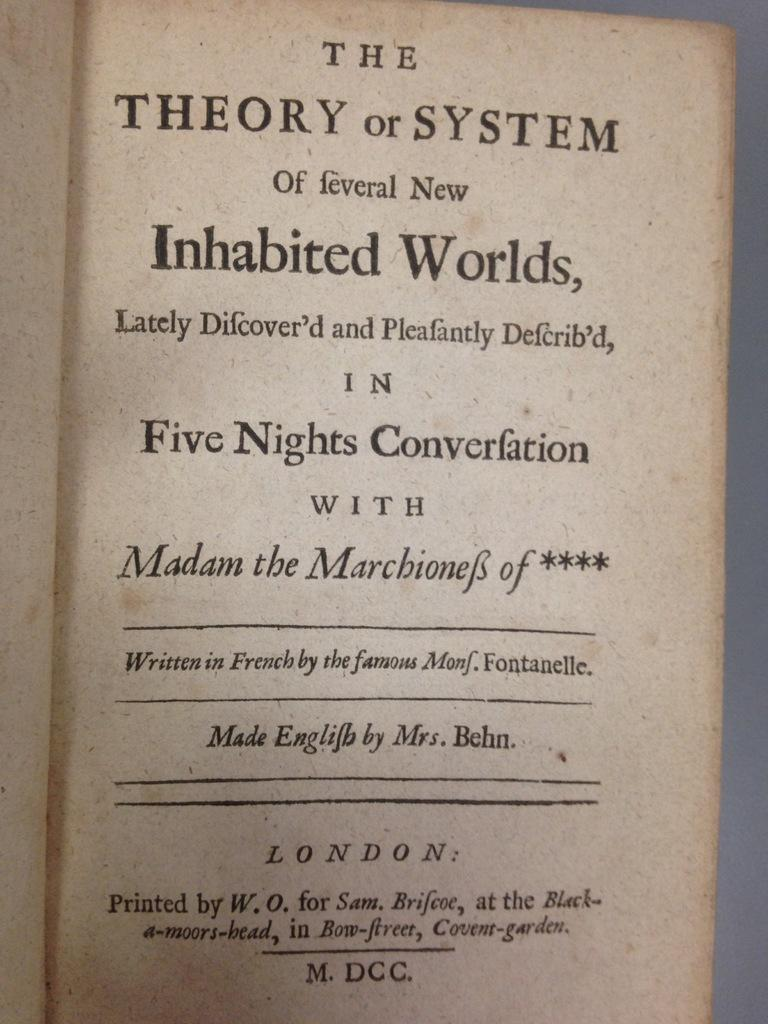<image>
Render a clear and concise summary of the photo. A book is open to a page reading "The Theory or system of feveral new inhabited worlds..." 